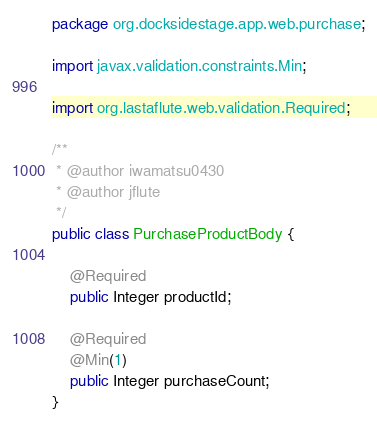<code> <loc_0><loc_0><loc_500><loc_500><_Java_>package org.docksidestage.app.web.purchase;

import javax.validation.constraints.Min;

import org.lastaflute.web.validation.Required;

/**
 * @author iwamatsu0430
 * @author jflute
 */
public class PurchaseProductBody {

    @Required
    public Integer productId;

    @Required
    @Min(1)
    public Integer purchaseCount;
}
</code> 